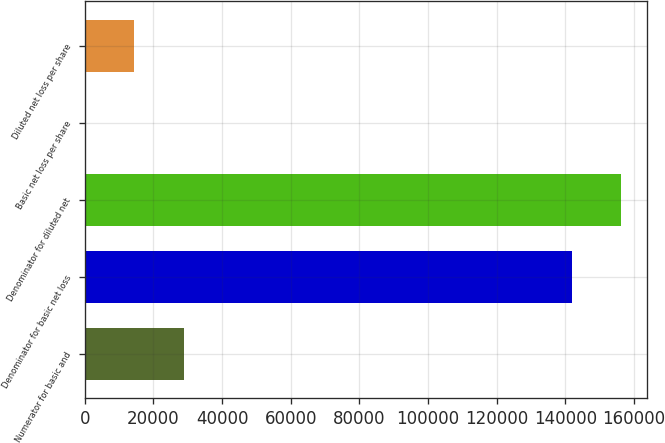Convert chart. <chart><loc_0><loc_0><loc_500><loc_500><bar_chart><fcel>Numerator for basic and<fcel>Denominator for basic net loss<fcel>Denominator for diluted net<fcel>Basic net loss per share<fcel>Diluted net loss per share<nl><fcel>28845<fcel>141937<fcel>156131<fcel>0.2<fcel>14193.9<nl></chart> 